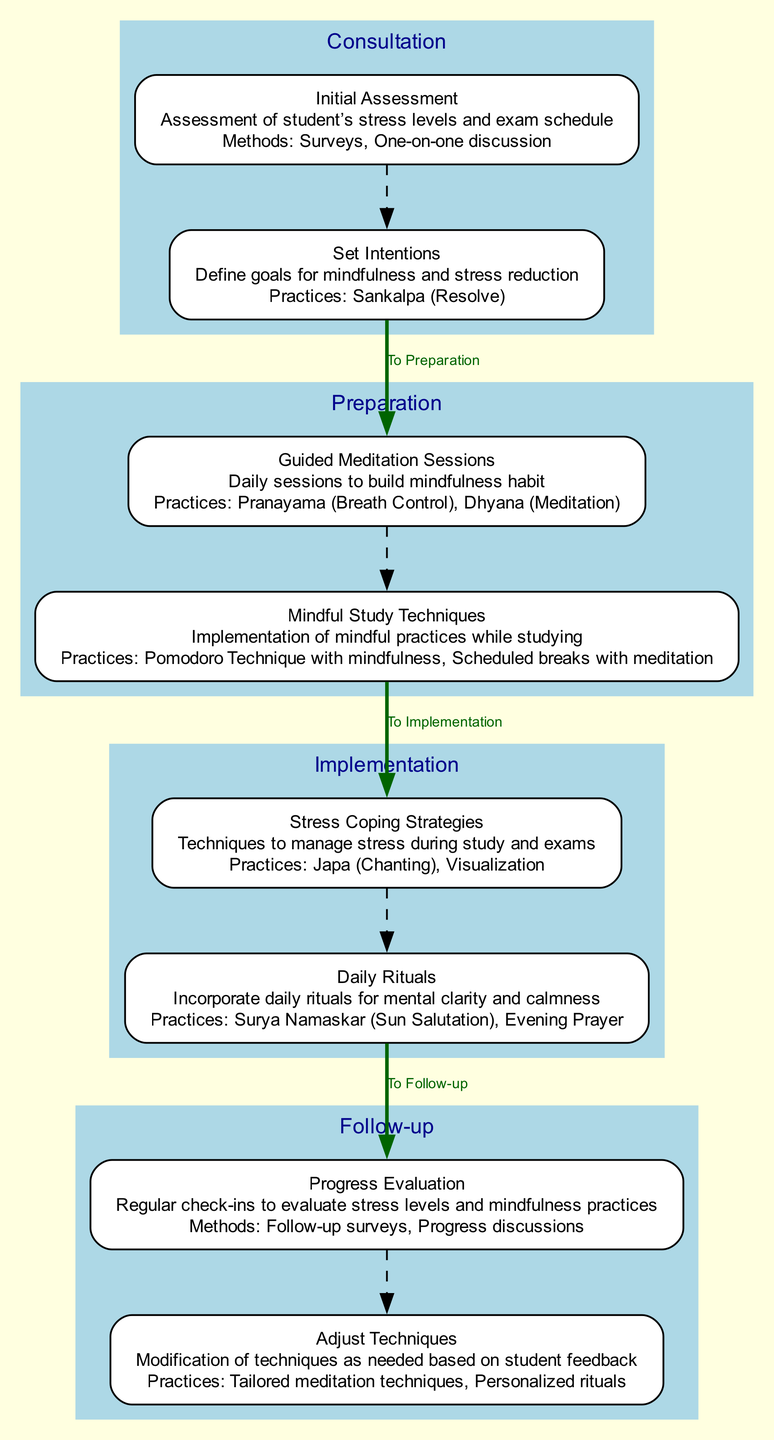What are the two main phases in the Clinical Pathway? The diagram shows four main phases: Consultation, Preparation, Implementation, and Follow-up. The two main phases from the first two in the order of the diagram are Consultation and Preparation.
Answer: Consultation, Preparation What practice is associated with the Initial Assessment? The Initial Assessment phase mentions two methods, Surveys and One-on-one discussion. However, it does not directly list a practice. The closest associated is the purpose of "assessment."
Answer: None How many elements are there in the Implementation phase? The Implementation phase includes two elements: Stress Coping Strategies and Daily Rituals. Counting them gives a total of two elements.
Answer: 2 Which practice is found in both the Preparation and Implementation phases? Reviewing both phases shows that daily practices relating to mindfulness appear in both. The practice "Meditation" appears in Preparation and "Daily Rituals" in Implementation. Therefore, 'Meditation' is common.
Answer: Meditation What is the method used during the Progress Evaluation? The Progress Evaluation includes the mention of Follow-up surveys and Progress discussions as methods. Both are effective for evaluation, but only surveys are explicitly mentioned for evaluating progress here.
Answer: Follow-up surveys Which phase comes after the Preparation phase? The diagram shows that after the Preparation phase, the next phase is Implementation, indicated by the direct connection between those two phases.
Answer: Implementation What practices are incorporated in Daily Rituals? The Daily Rituals mention two practices: Surya Namaskar (Sun Salutation) and Evening Prayer. Both are explicitly listed under that element.
Answer: Surya Namaskar, Evening Prayer What is used to manage stress during exams in the Implementation phase? The Implementation phase lists Stress Coping Strategies that include techniques like Japa (Chanting) and Visualization specifically for managing stress during exams.
Answer: Japa, Visualization What type of check-ins occur in the Follow-up phase? The Follow-up phase mentions Progress Evaluation which implies regular check-ins with students to evaluate their stress levels and mindfulness practices. Thus, the check-ins relate to progress evaluation.
Answer: Progress Evaluation 